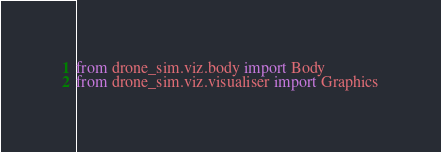Convert code to text. <code><loc_0><loc_0><loc_500><loc_500><_Python_>from drone_sim.viz.body import Body
from drone_sim.viz.visualiser import Graphics</code> 